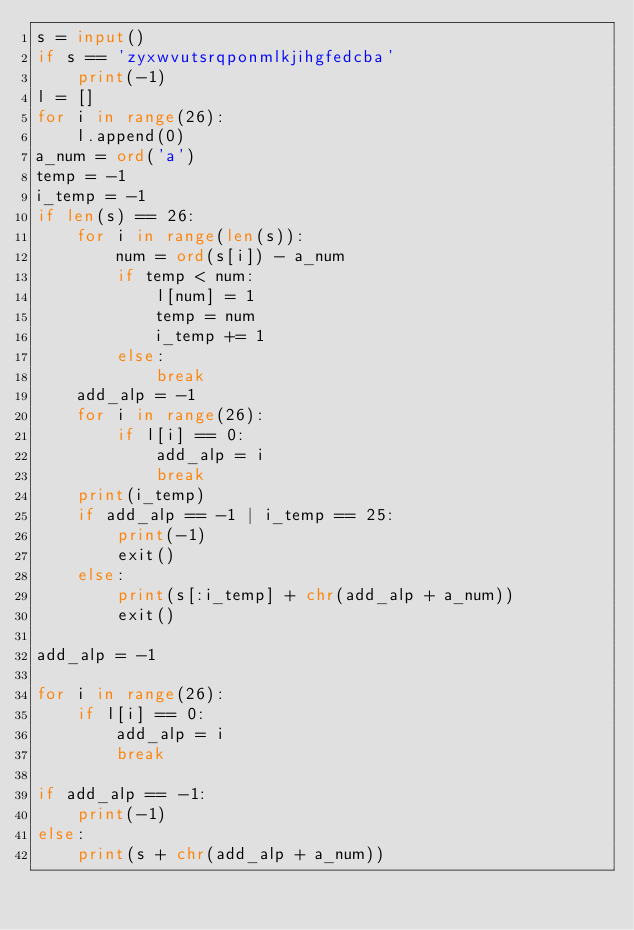<code> <loc_0><loc_0><loc_500><loc_500><_Python_>s = input()
if s == 'zyxwvutsrqponmlkjihgfedcba'
    print(-1)
l = []
for i in range(26):
    l.append(0)
a_num = ord('a')
temp = -1
i_temp = -1
if len(s) == 26:
    for i in range(len(s)):
        num = ord(s[i]) - a_num
        if temp < num:
            l[num] = 1
            temp = num
            i_temp += 1
        else:
            break
    add_alp = -1
    for i in range(26):
        if l[i] == 0:
            add_alp = i
            break
    print(i_temp)
    if add_alp == -1 | i_temp == 25:
        print(-1)
        exit()
    else:
        print(s[:i_temp] + chr(add_alp + a_num))
        exit()

add_alp = -1

for i in range(26):
    if l[i] == 0:
        add_alp = i
        break

if add_alp == -1:
    print(-1)
else:
    print(s + chr(add_alp + a_num))
</code> 